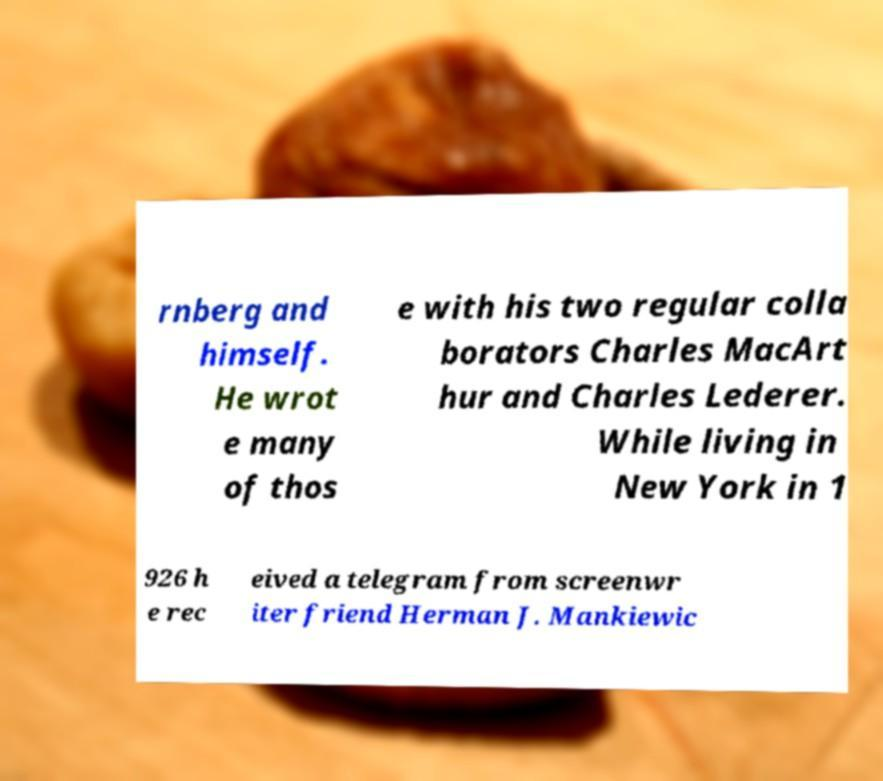For documentation purposes, I need the text within this image transcribed. Could you provide that? rnberg and himself. He wrot e many of thos e with his two regular colla borators Charles MacArt hur and Charles Lederer. While living in New York in 1 926 h e rec eived a telegram from screenwr iter friend Herman J. Mankiewic 